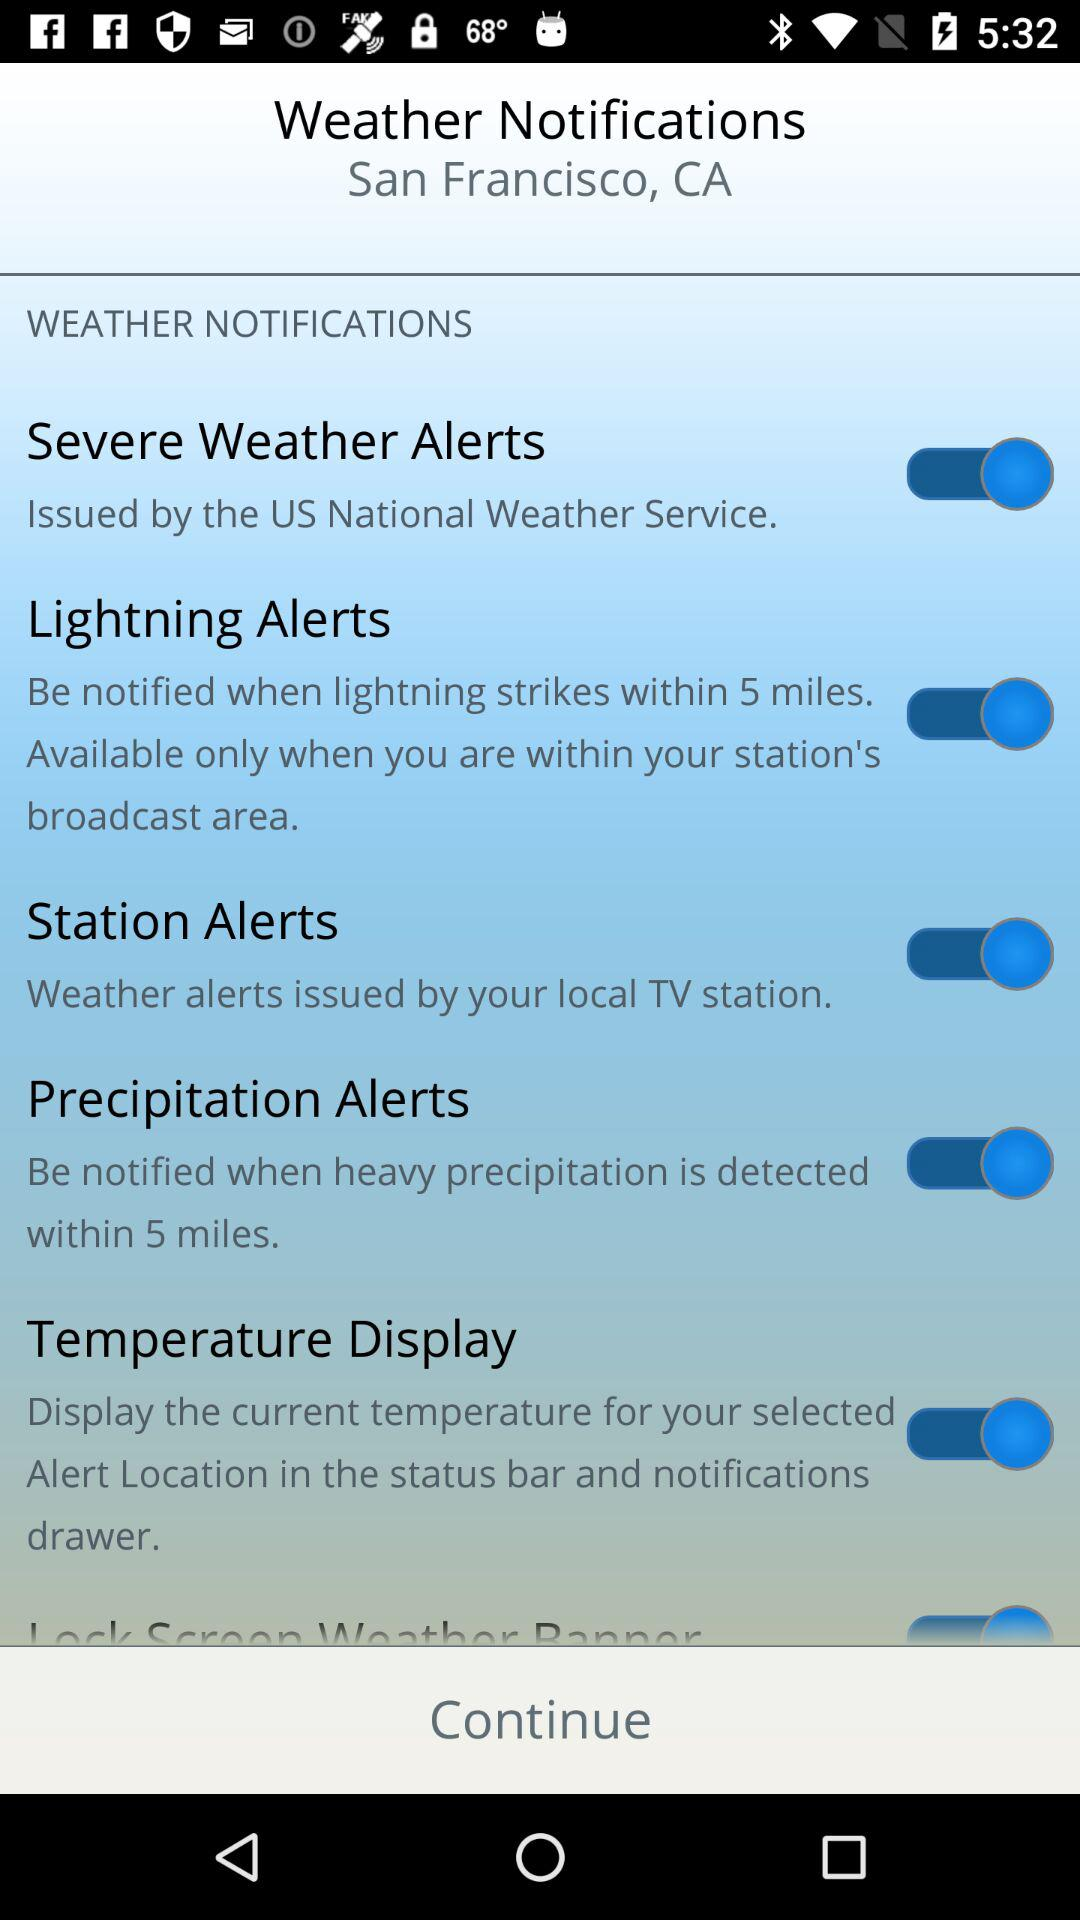By what service were the severe weather alerts issued? The severe weather alerts were issued by the US National Weather Service. 